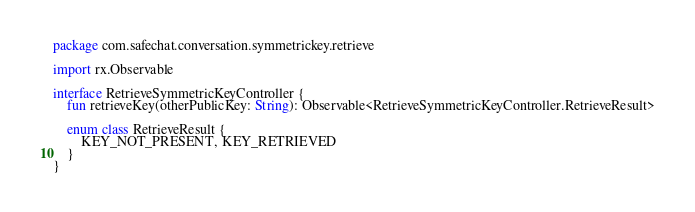Convert code to text. <code><loc_0><loc_0><loc_500><loc_500><_Kotlin_>package com.safechat.conversation.symmetrickey.retrieve

import rx.Observable

interface RetrieveSymmetricKeyController {
    fun retrieveKey(otherPublicKey: String): Observable<RetrieveSymmetricKeyController.RetrieveResult>

    enum class RetrieveResult {
        KEY_NOT_PRESENT, KEY_RETRIEVED
    }
}</code> 